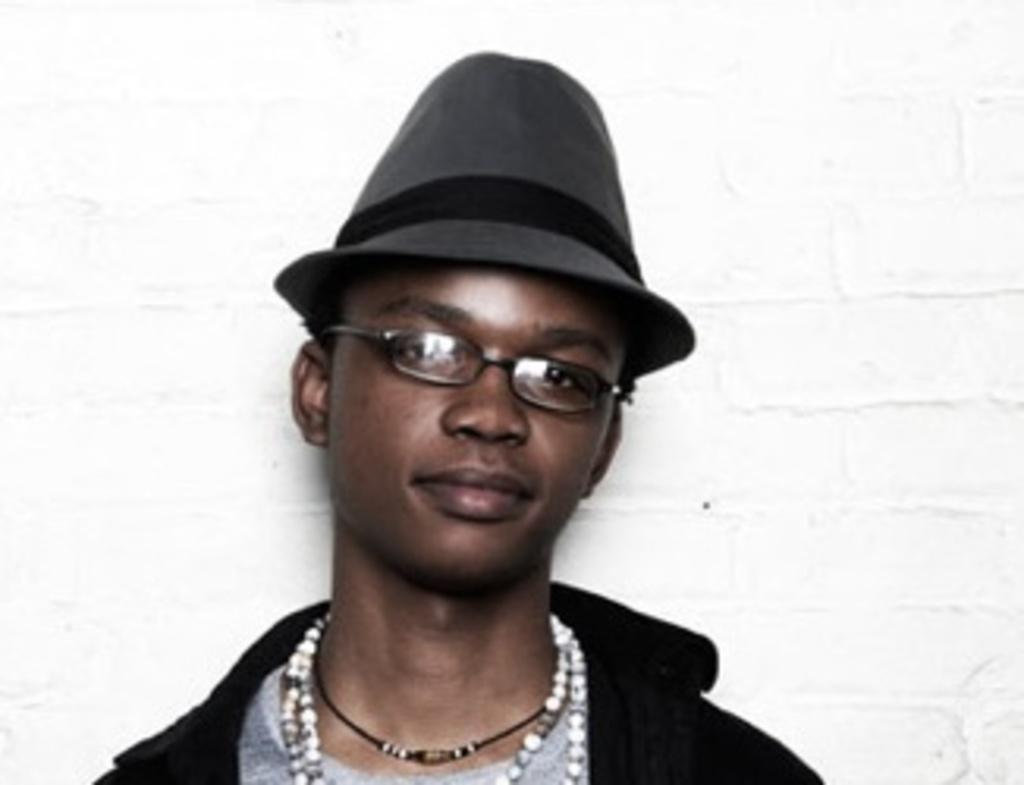Who is present in the image? There is a man in the image. What is the man wearing in the image? The man is wearing a black jacket and glasses. What is the color of the background in the image? The background of the image is white. What type of stick can be seen in the man's hand in the image? There is no stick present in the man's hand or in the image. 